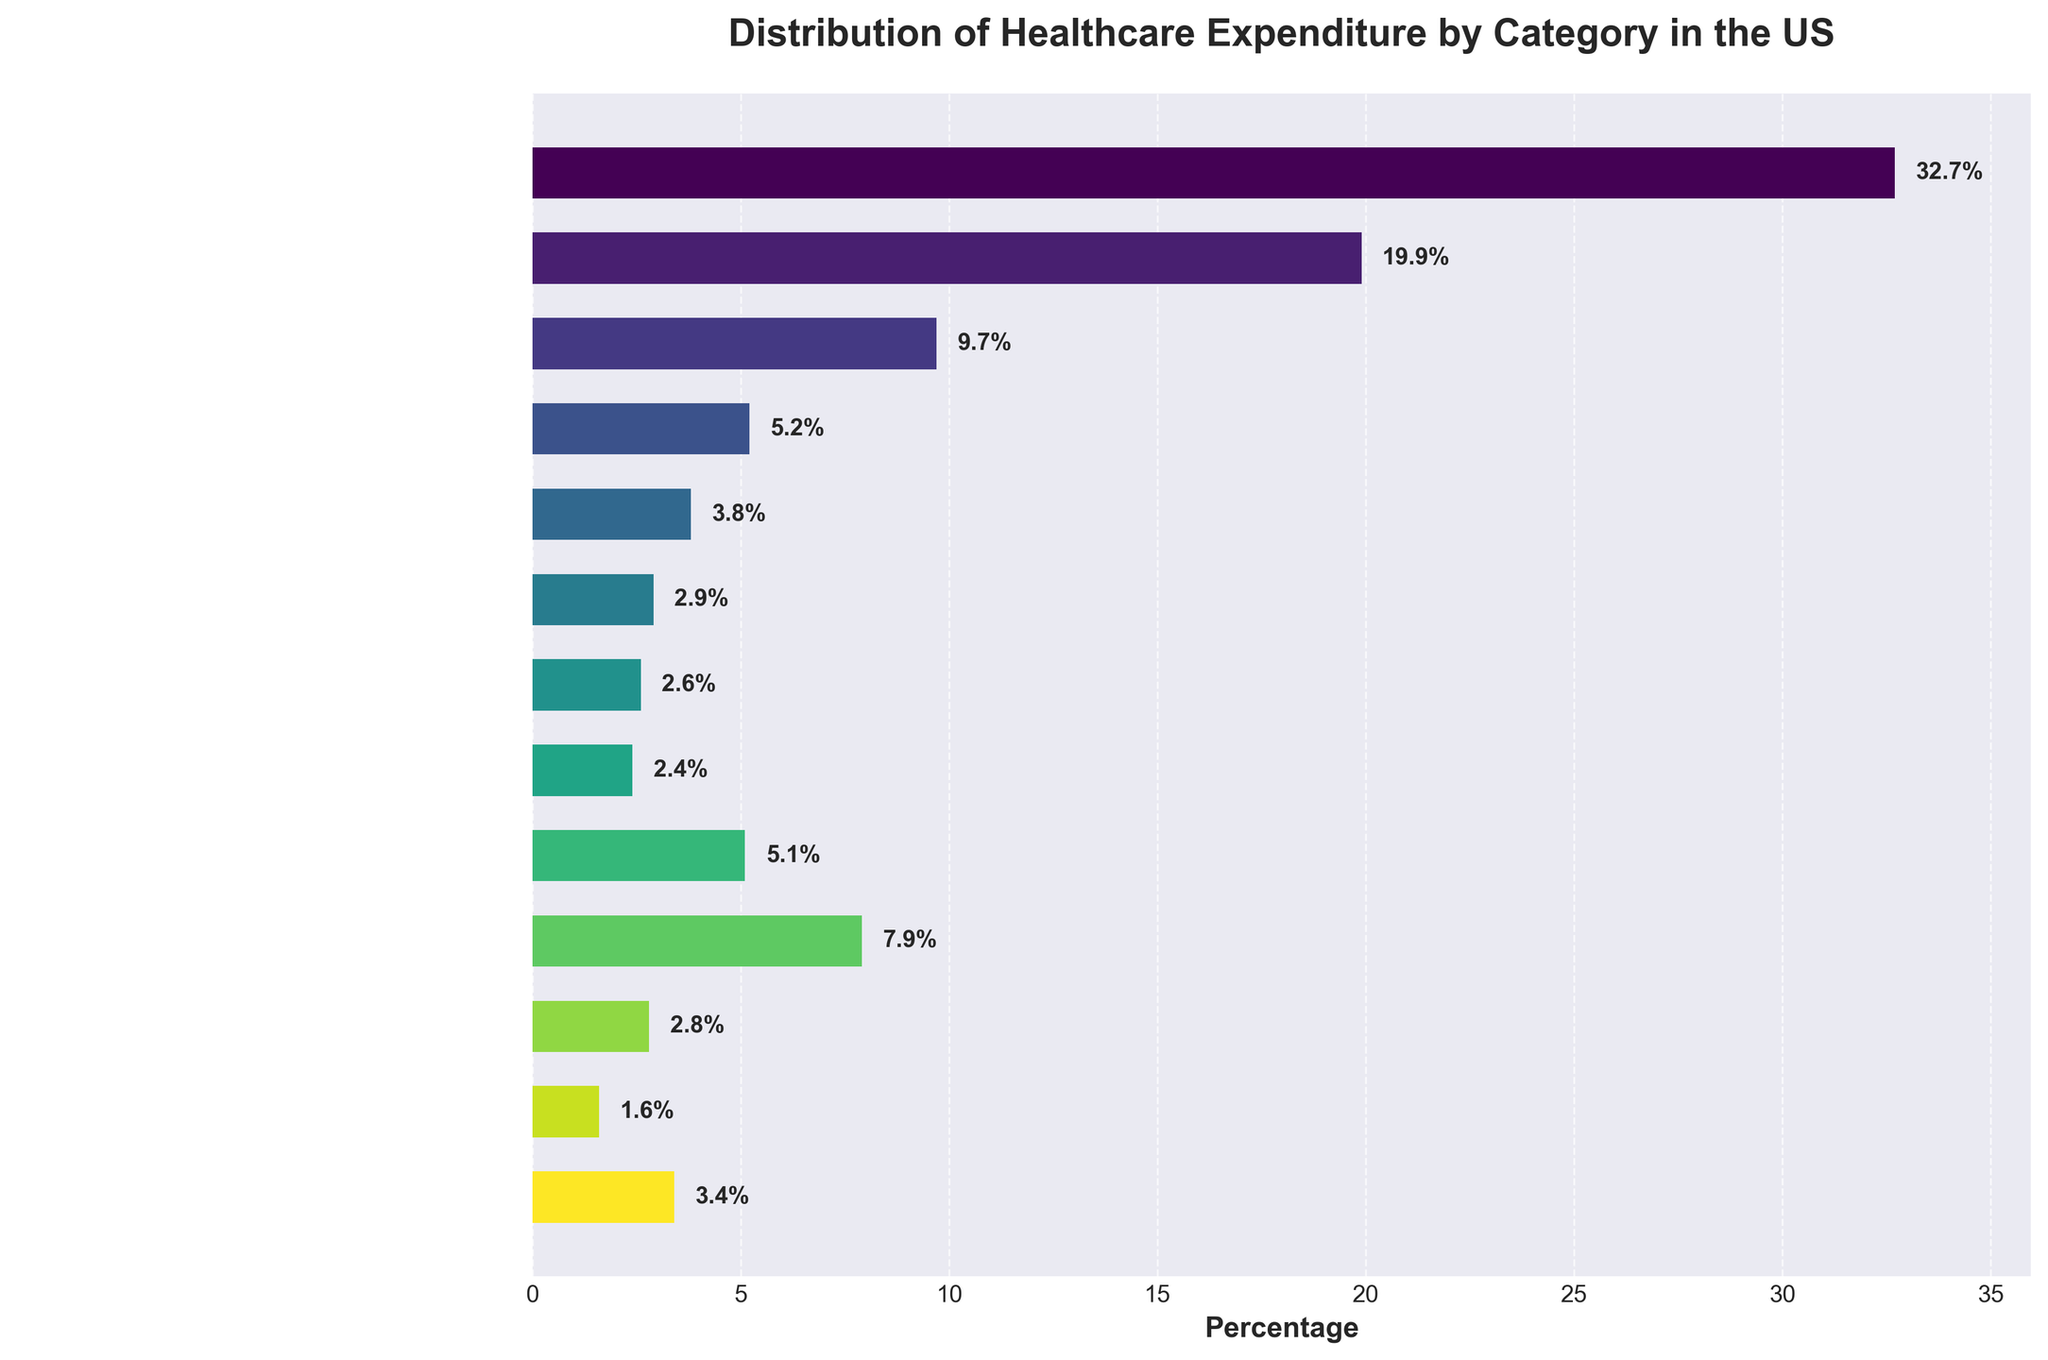What percentage of healthcare expenditure is spent on hospitals and prescription drugs combined? Add the percentages for hospitals and prescription drugs: 32.7% + 9.7% = 42.4%
Answer: 42.4% Which category has the highest healthcare expenditure percentage? The bar representing hospitals is the longest, indicating the highest expenditure percentage of 32.7%
Answer: Hospitals How much higher is the percentage of expenditure on physician and clinical services compared to nursing care facilities? Subtract the percentage for nursing care facilities from the percentage for physician and clinical services: 19.9% - 5.2% = 14.7%
Answer: 14.7% What is the total percentage of expenditures for dental services, home health care, and other professional services? Add the percentages for these three categories: 3.8% + 2.9% + 2.6% = 9.3%
Answer: 9.3% Which category has a lower expenditure percentage: government administration or other health care? Compare the percentages for government administration (7.9%) and other health care (3.4%). 3.4% is less than 7.9%
Answer: Other health care What is the average percentage expenditure of the categories: medical equipment and products, government public health activities, and investment in research? Sum their percentages and divide by the number of categories: (2.4% + 2.8% + 1.6%) / 3 = 6.8% / 3 = 2.27%
Answer: 2.27% Which category has the smallest percentage of healthcare expenditure? The bar representing investment in research is the shortest, indicating the smallest expenditure of 1.6%
Answer: Investment in research Is the combined expenditure on other health residential and personal care, and home health care greater than the expenditure on physician and clinical services? Calculate the combined percentage for other health residential and personal care, and home health care: 5.1% + 2.9% = 8%. Compare it to physician and clinical services (19.9%). 8% is less than 19.9%
Answer: No How does the expenditure on nursing care facilities compare visually to that on dental services? The bar for nursing care facilities is longer than the bar for dental services, indicating higher expenditure
Answer: Nursing care facilities have higher expenditure What's the percentage difference between the category with the highest expenditure and the category with the lowest? Subtract the lowest percentage (investment in research, 1.6%) from the highest percentage (hospitals, 32.7%): 32.7% - 1.6% = 31.1%
Answer: 31.1% 